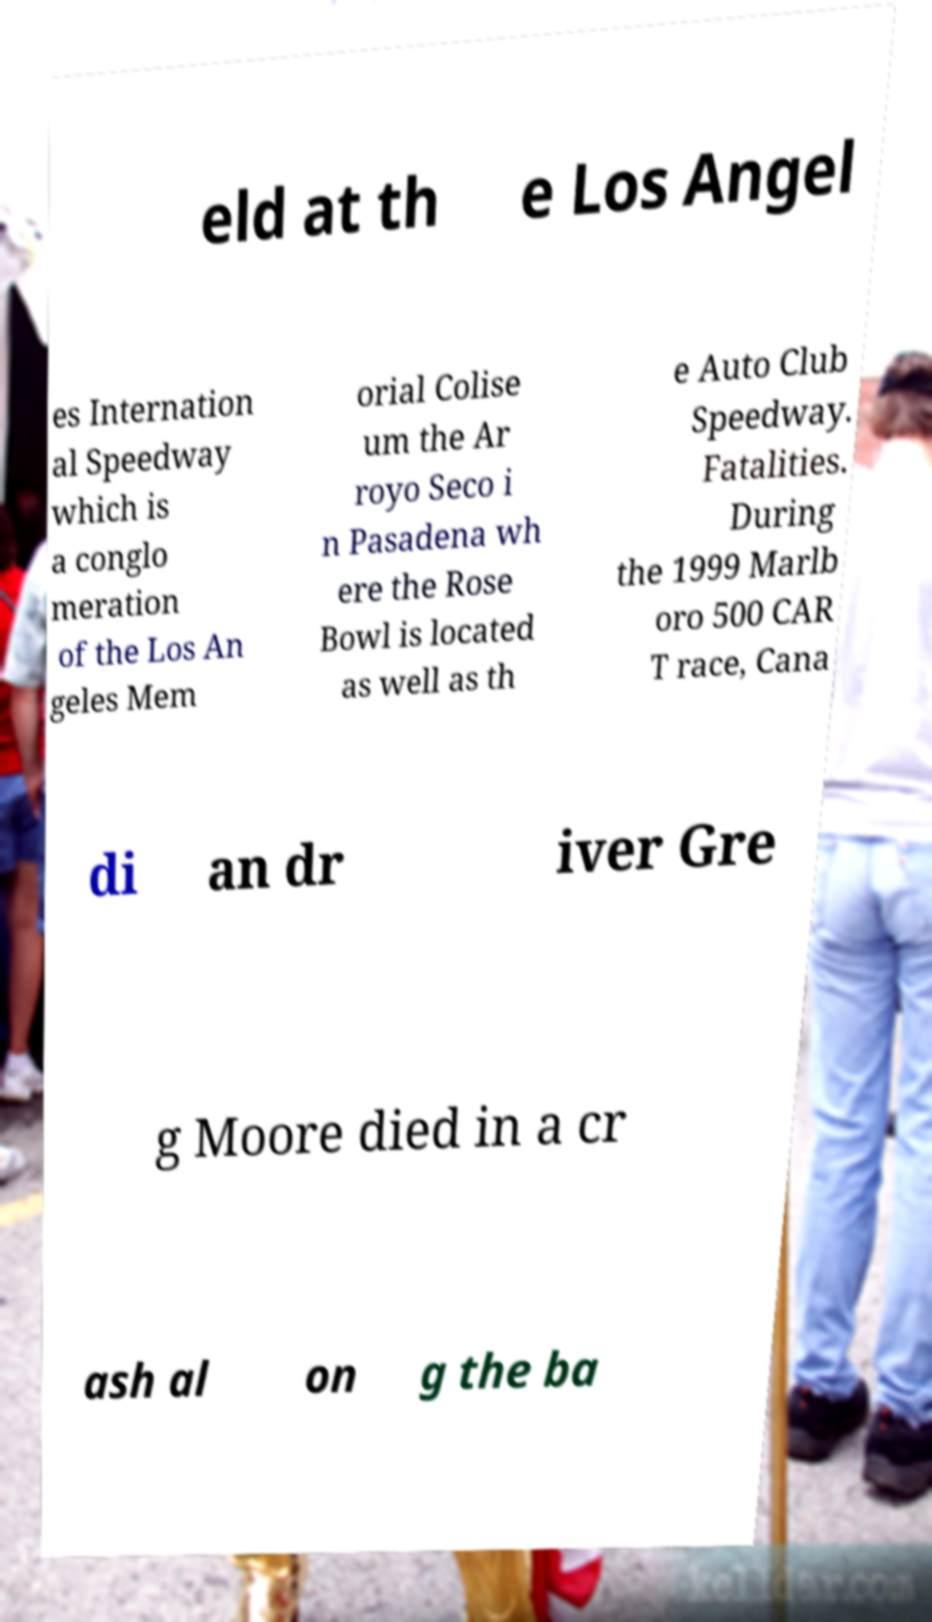I need the written content from this picture converted into text. Can you do that? eld at th e Los Angel es Internation al Speedway which is a conglo meration of the Los An geles Mem orial Colise um the Ar royo Seco i n Pasadena wh ere the Rose Bowl is located as well as th e Auto Club Speedway. Fatalities. During the 1999 Marlb oro 500 CAR T race, Cana di an dr iver Gre g Moore died in a cr ash al on g the ba 